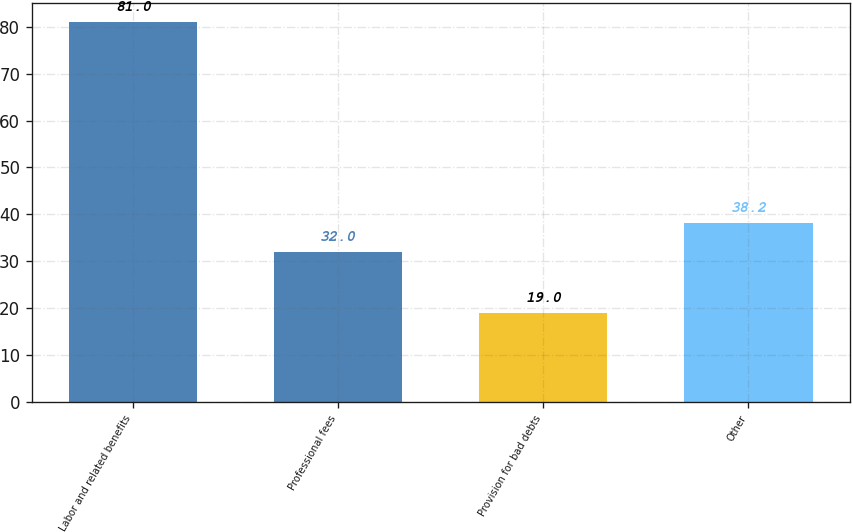Convert chart to OTSL. <chart><loc_0><loc_0><loc_500><loc_500><bar_chart><fcel>Labor and related benefits<fcel>Professional fees<fcel>Provision for bad debts<fcel>Other<nl><fcel>81<fcel>32<fcel>19<fcel>38.2<nl></chart> 